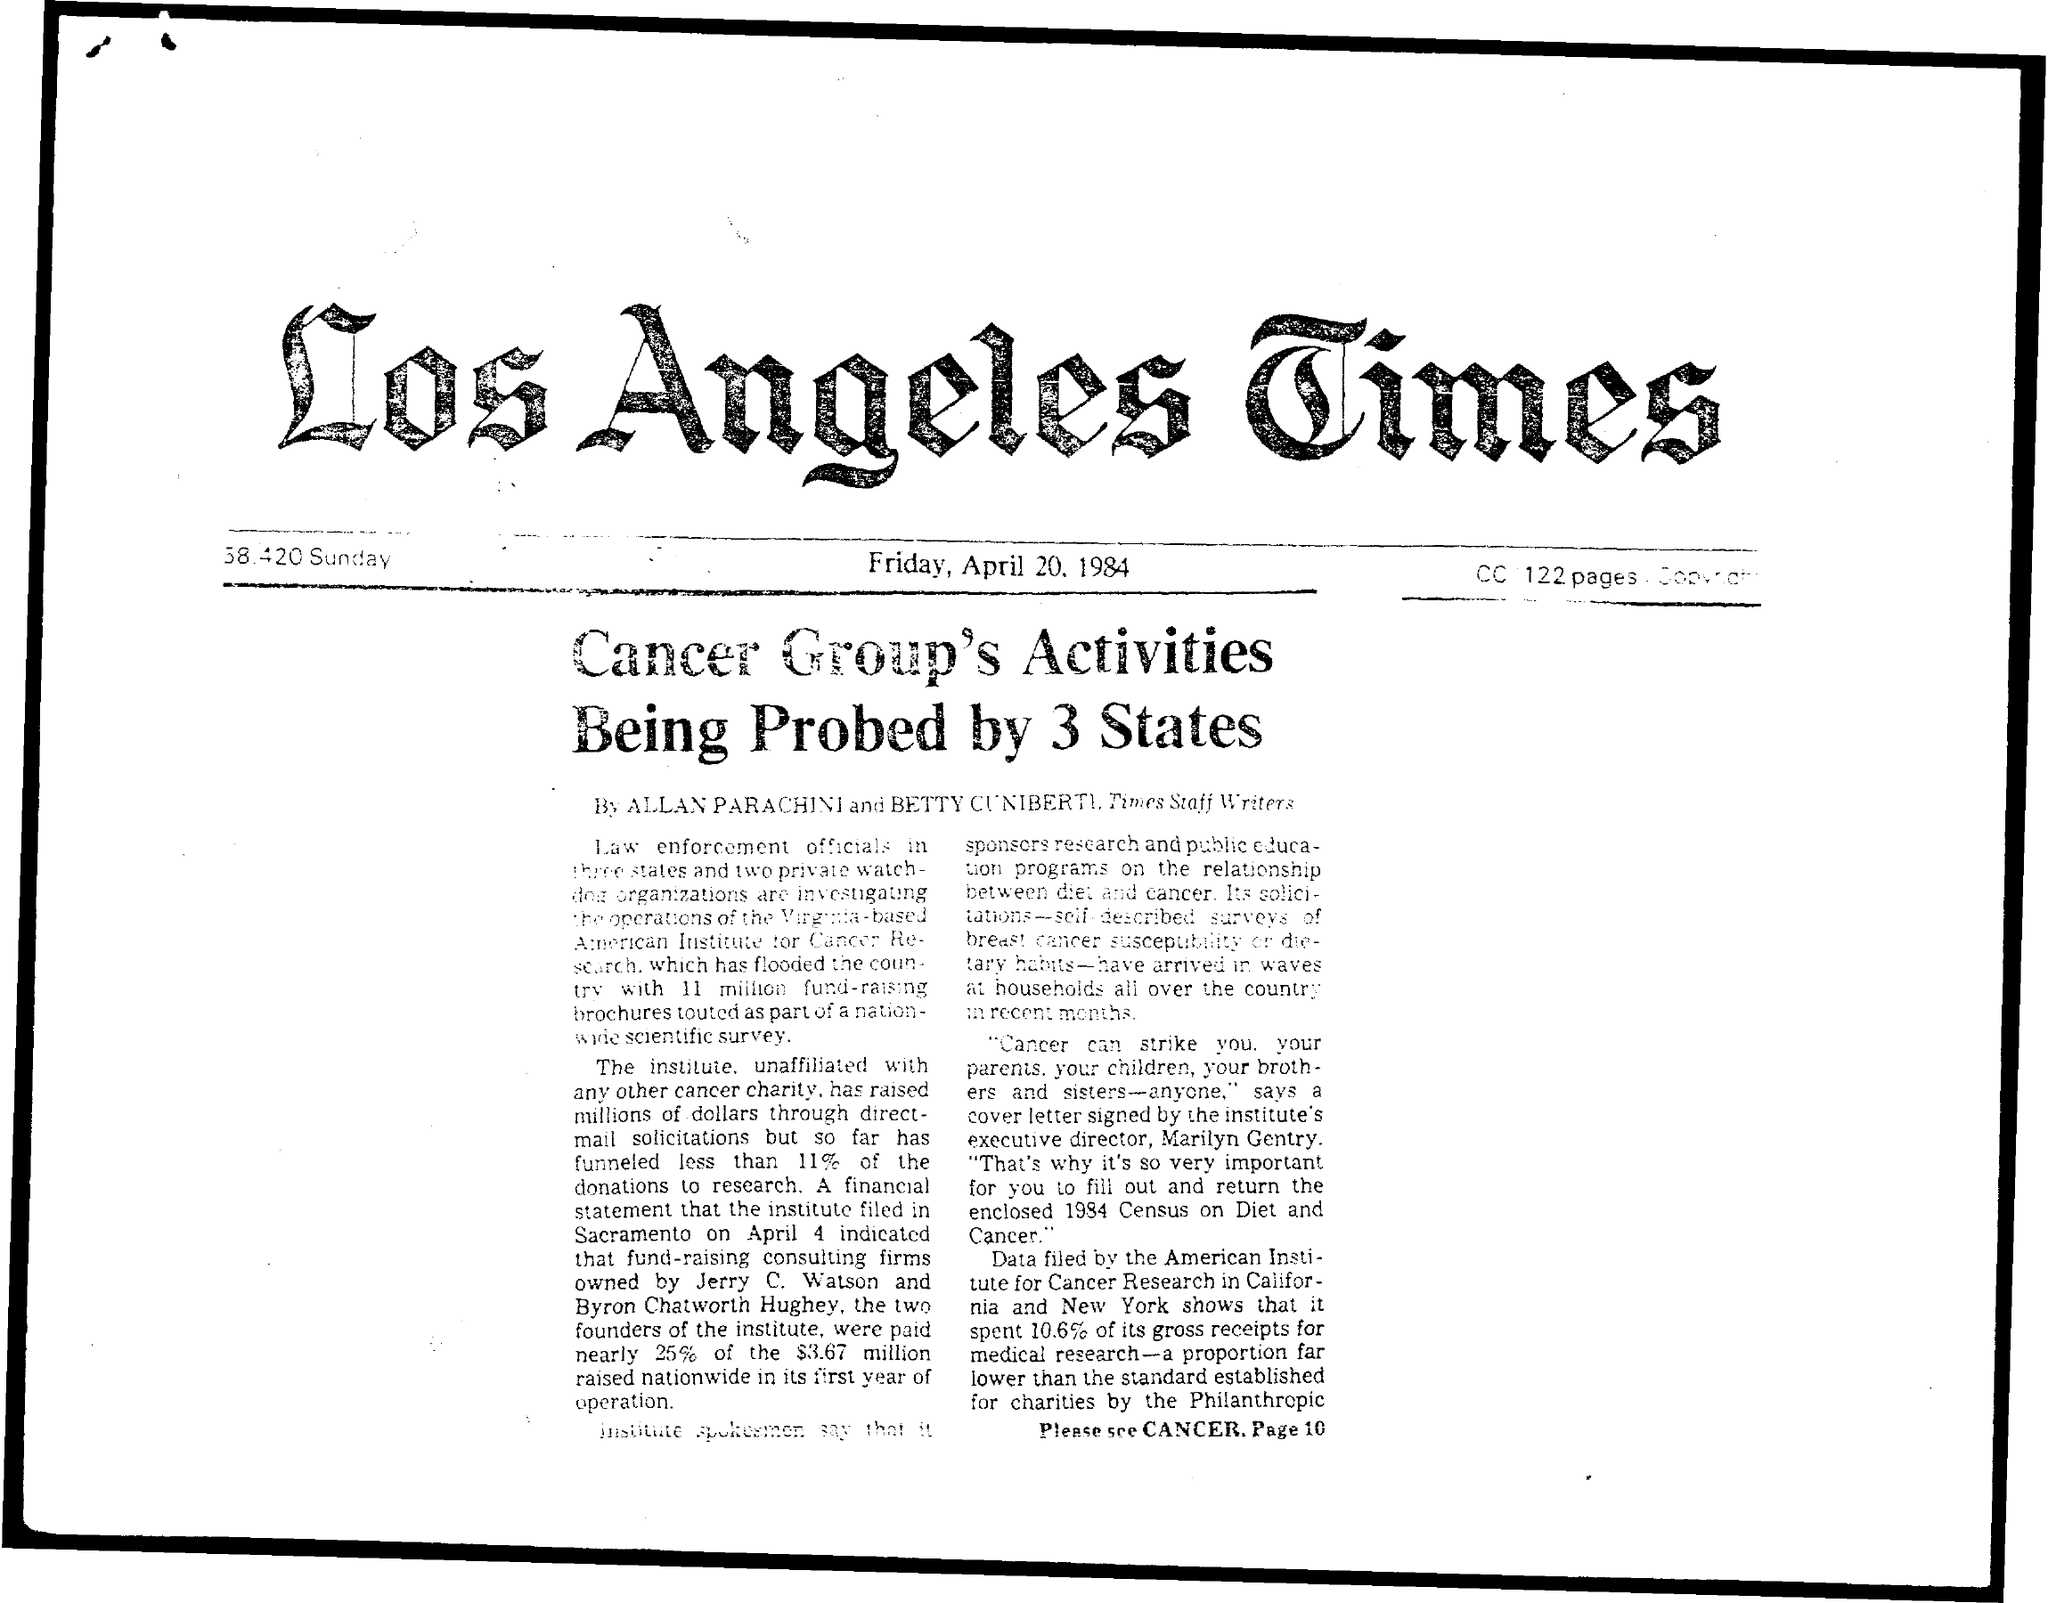How many pages are mentioned in the cc?
Your answer should be compact. 122. 